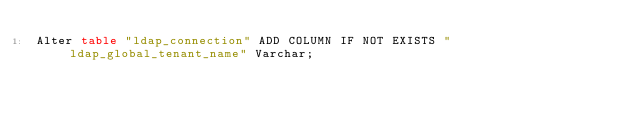<code> <loc_0><loc_0><loc_500><loc_500><_SQL_>Alter table "ldap_connection" ADD COLUMN IF NOT EXISTS "ldap_global_tenant_name" Varchar;
</code> 